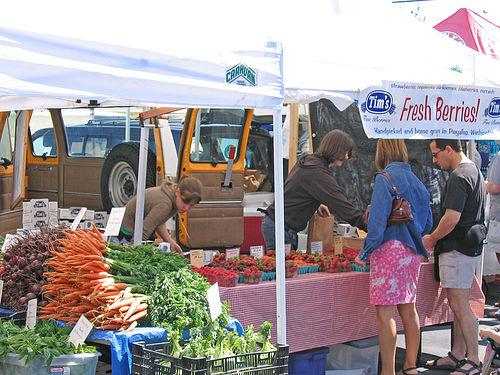What type of vegetables can be seen on the table? On the table, we can see carrots, radishes, green vegetables in a black plastic crate, red potatoes, and tomatoes. Explain what the people in the image are doing. The people in the image are possibly buying vegetables at the vegetable stand, where a woman might be helping customers. Name a smaller accessory that appears in the image and describe its appearance. There is a silver handle with a red tip in the image, possibly attached to a container. Comment on the signs and banners present in the image. There are signs for "Tims Fresh Berries" and fresh vegetables along with red, white, and blue banners. Mention the vehicle in the image and describe its appearance. There is a yellow van with doors open and a spare tire attached to the side, possibly an orange and brown truck as well. Describe the man's footwear and trousers. The man is wearing black sandals on his white male feet and beige pants. Describe the objects on the table and the tablecloth's design. The table has a red checkered tablecloth and is covered with a variety of vegetables like carrots, radishes, and potatoes. There are also strawberries and fresh berries, and a small sign for the vegetables. Identify the two main people in the image and describe their outfits. A woman is wearing a blue shirt, brown purse, and pink and white spotted skirt, and a man has on a short sleeve black shirt, beige pants, and black sandals. Name a container available for storing vegetables and its color. There is a light blue crate full of vegetables. List three pieces of clothing worn by the woman in the blue shirt. Woman in the blue shirt is wearing a pink and white spotted skirt, a brown purse, and a pink and white shirt. 